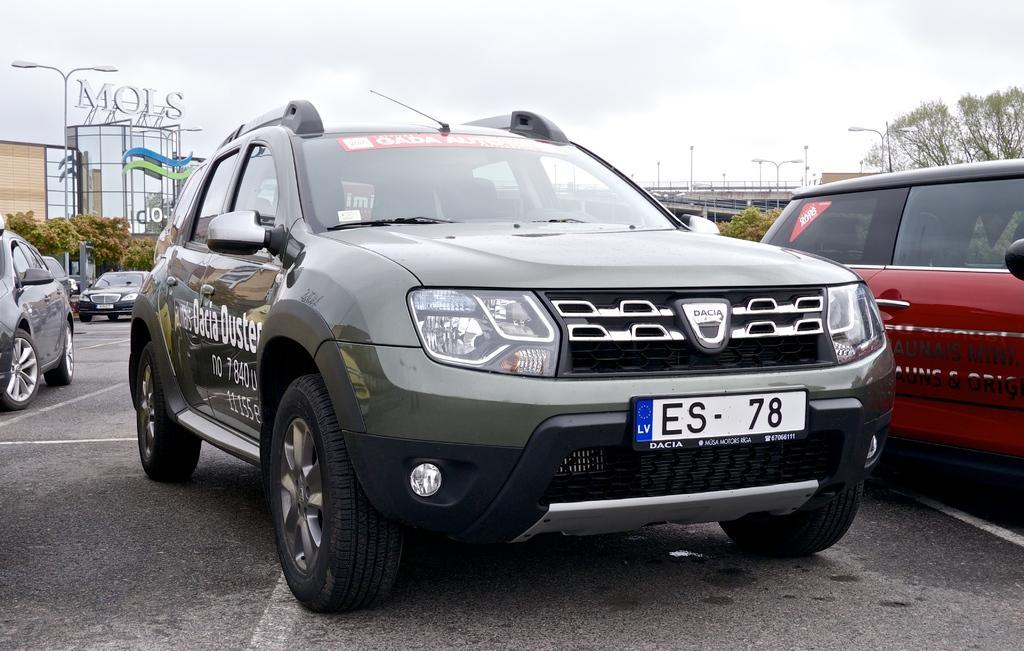Can you describe this image briefly? In this picture I see the road in front on which there are few cars and I see something is written on this car which is in the middle of this image. In the background I see the trees, light poles and the sky. 